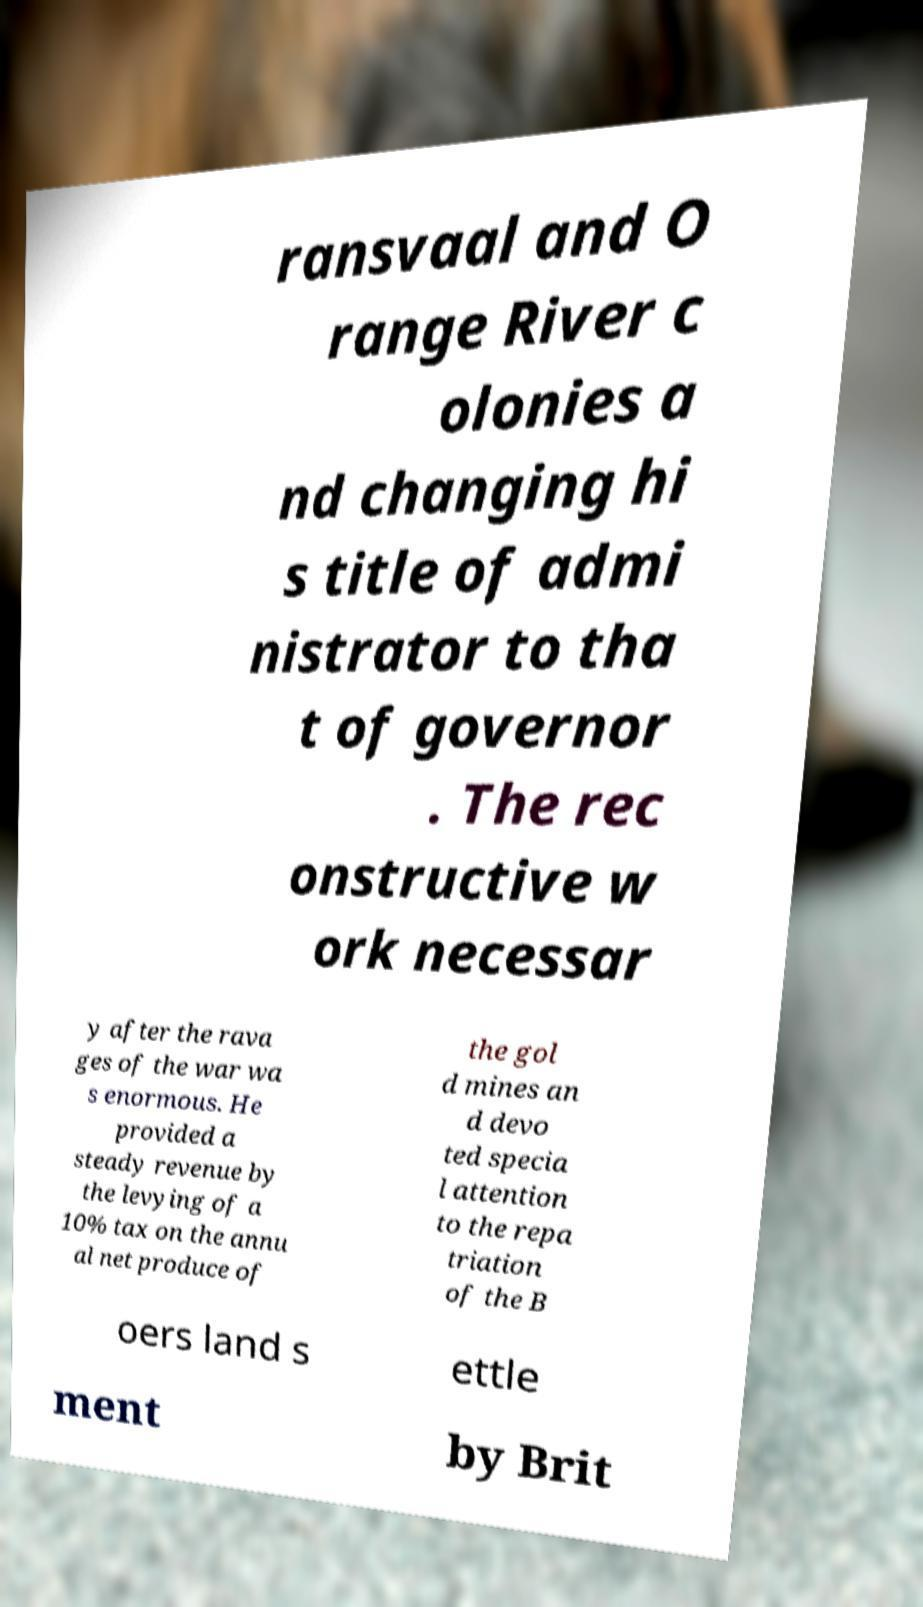Please read and relay the text visible in this image. What does it say? ransvaal and O range River c olonies a nd changing hi s title of admi nistrator to tha t of governor . The rec onstructive w ork necessar y after the rava ges of the war wa s enormous. He provided a steady revenue by the levying of a 10% tax on the annu al net produce of the gol d mines an d devo ted specia l attention to the repa triation of the B oers land s ettle ment by Brit 